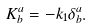<formula> <loc_0><loc_0><loc_500><loc_500>K ^ { a } _ { b } = - k _ { 1 } \delta ^ { a } _ { b } .</formula> 